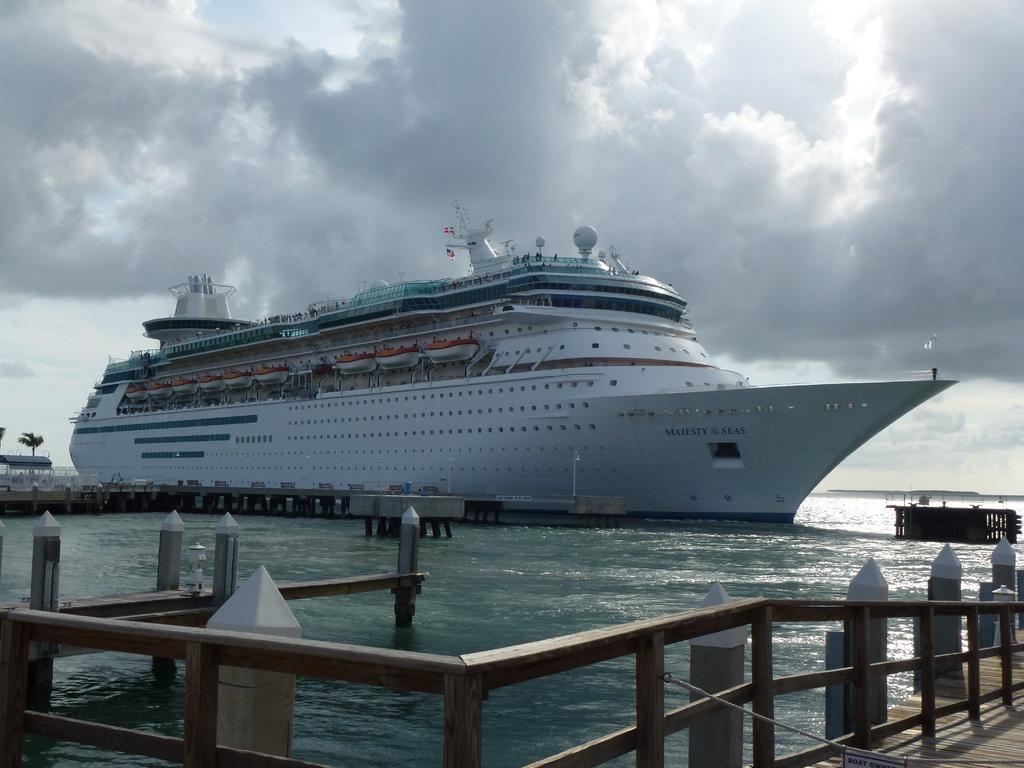What type of vehicle is in the seawater in the image? There is a white cruise ship in the seawater in the image. What feature can be seen at the front of the ship? There is a wooden railing in the front of the ship. What is visible at the top of the image? The sky is visible at the top of the image. What can be observed in the sky? Clouds are present in the sky. What type of mouth can be seen on the cruise ship in the image? There is no mouth present on the cruise ship in the image. 